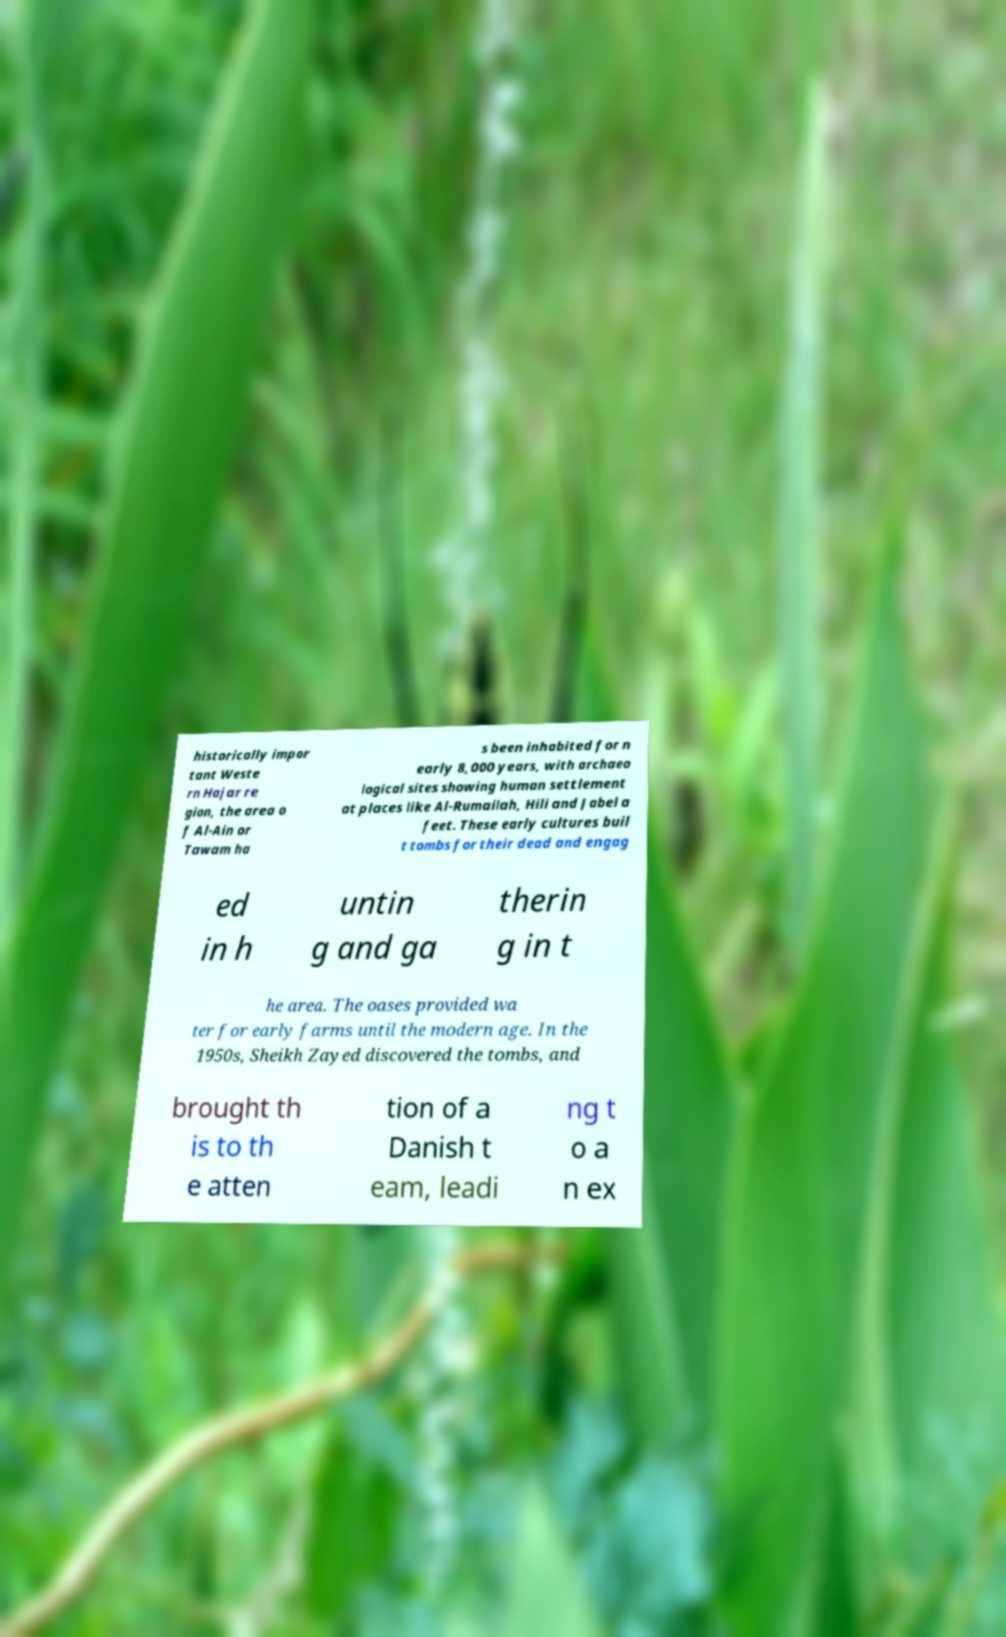Could you extract and type out the text from this image? historically impor tant Weste rn Hajar re gion, the area o f Al-Ain or Tawam ha s been inhabited for n early 8,000 years, with archaeo logical sites showing human settlement at places like Al-Rumailah, Hili and Jabel a feet. These early cultures buil t tombs for their dead and engag ed in h untin g and ga therin g in t he area. The oases provided wa ter for early farms until the modern age. In the 1950s, Sheikh Zayed discovered the tombs, and brought th is to th e atten tion of a Danish t eam, leadi ng t o a n ex 